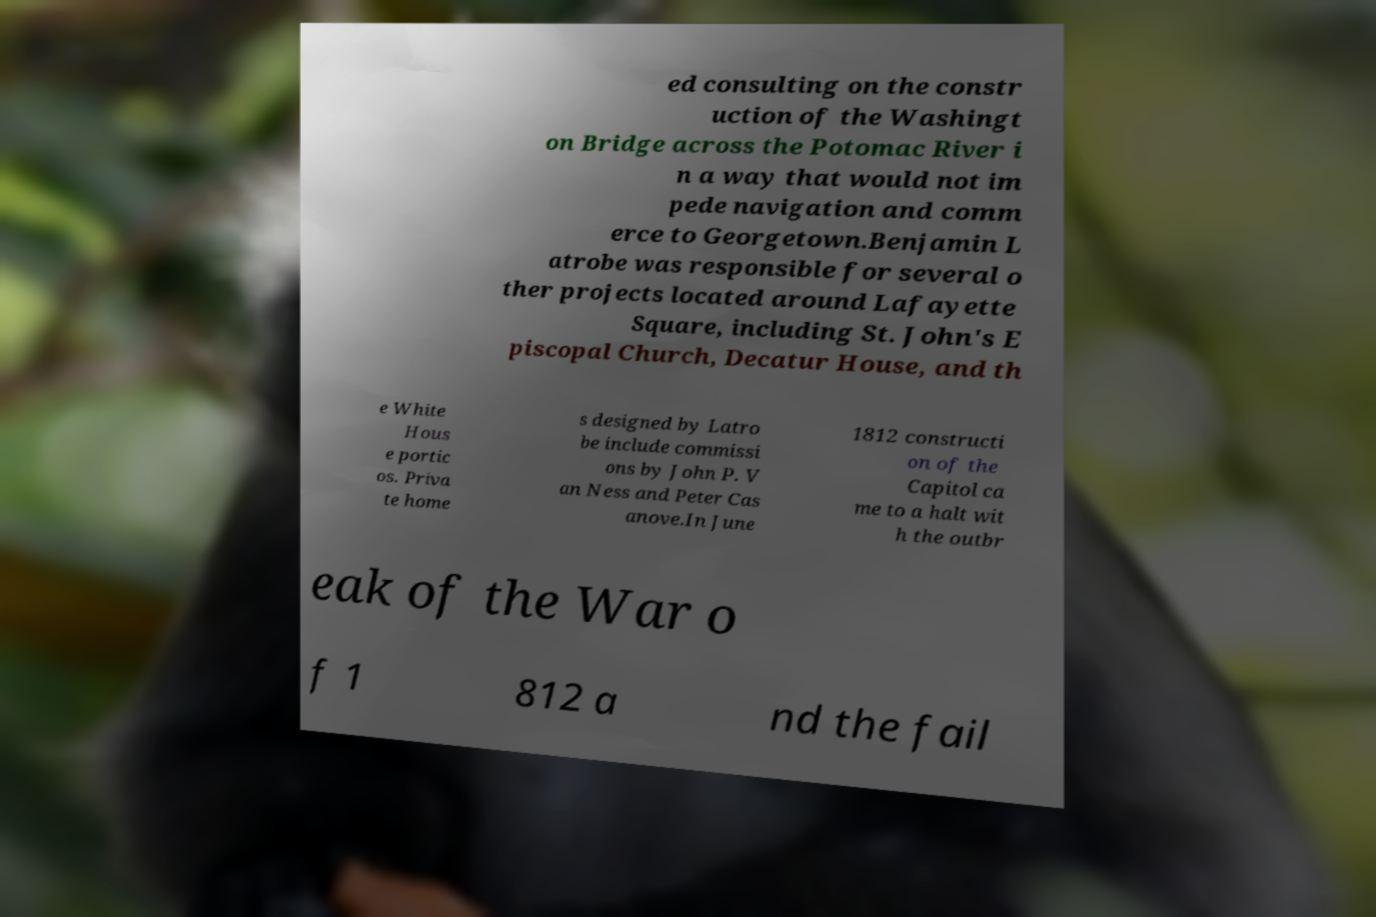Please read and relay the text visible in this image. What does it say? ed consulting on the constr uction of the Washingt on Bridge across the Potomac River i n a way that would not im pede navigation and comm erce to Georgetown.Benjamin L atrobe was responsible for several o ther projects located around Lafayette Square, including St. John's E piscopal Church, Decatur House, and th e White Hous e portic os. Priva te home s designed by Latro be include commissi ons by John P. V an Ness and Peter Cas anove.In June 1812 constructi on of the Capitol ca me to a halt wit h the outbr eak of the War o f 1 812 a nd the fail 